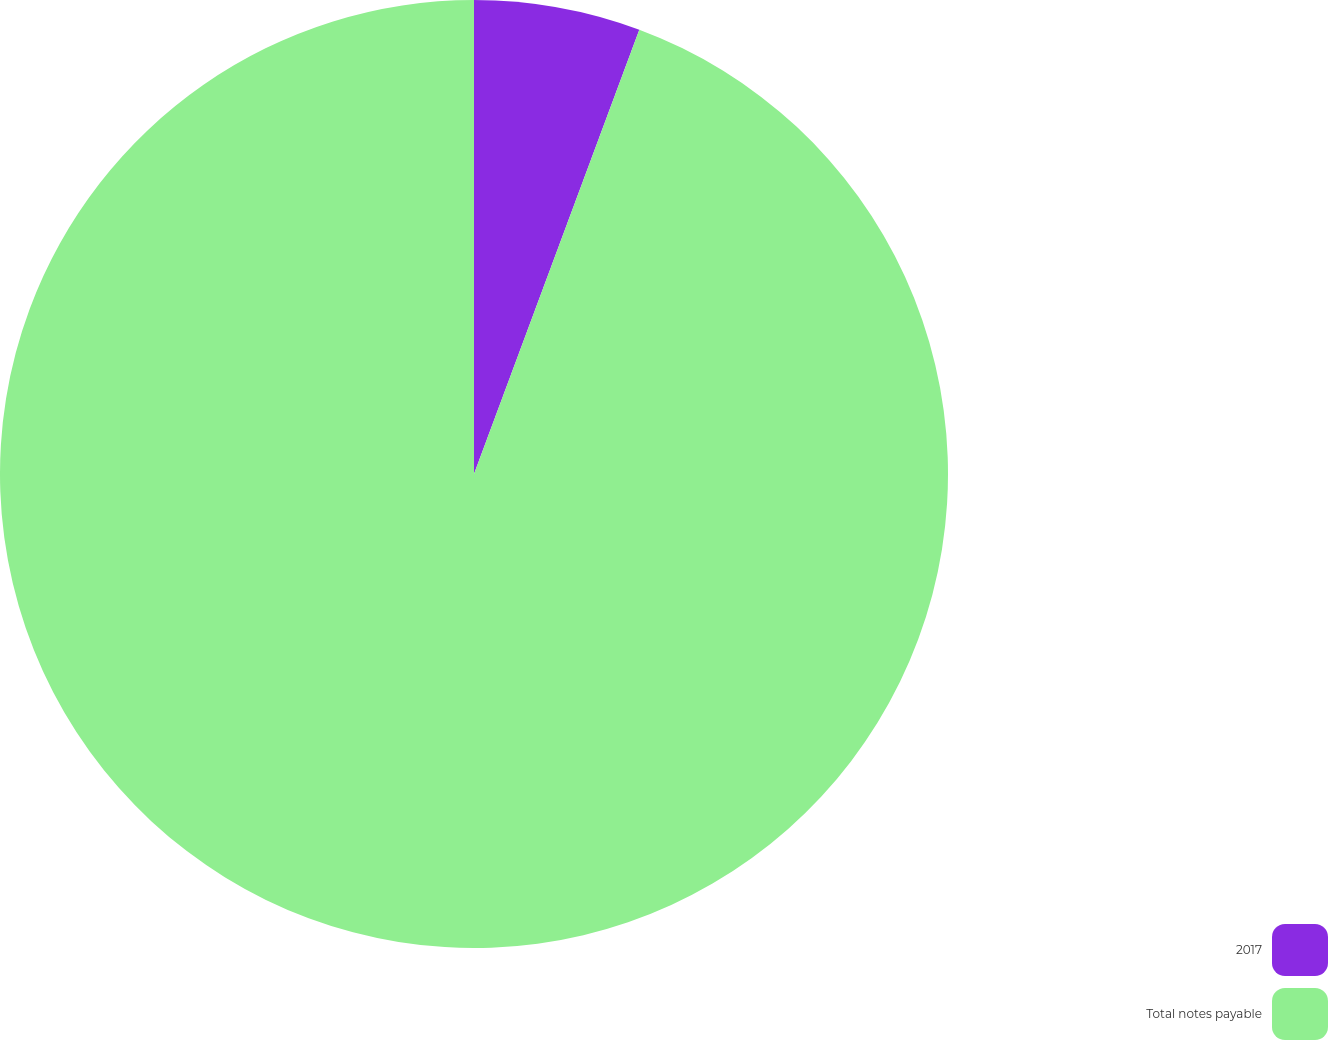<chart> <loc_0><loc_0><loc_500><loc_500><pie_chart><fcel>2017<fcel>Total notes payable<nl><fcel>5.67%<fcel>94.33%<nl></chart> 